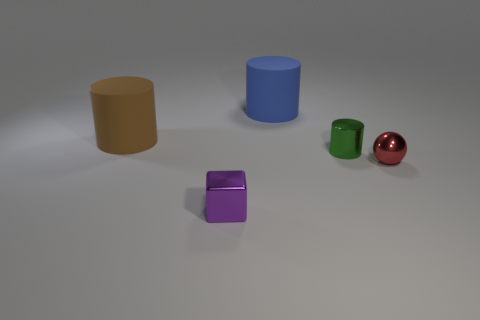There is a blue thing on the left side of the small metallic object that is behind the metal sphere; what number of large rubber cylinders are to the left of it?
Your answer should be very brief. 1. There is a matte cylinder that is on the right side of the brown matte cylinder; what number of metal things are on the left side of it?
Ensure brevity in your answer.  1. How many large brown things are behind the tiny green cylinder?
Your answer should be compact. 1. How many other things are the same size as the green shiny object?
Your answer should be compact. 2. What is the size of the other rubber object that is the same shape as the brown object?
Offer a very short reply. Large. What shape is the shiny thing that is in front of the small ball?
Keep it short and to the point. Cube. There is a small metallic object to the right of the shiny thing that is behind the red sphere; what color is it?
Your response must be concise. Red. What number of objects are big cylinders on the left side of the cube or shiny blocks?
Provide a succinct answer. 2. There is a blue object; does it have the same size as the shiny object behind the ball?
Make the answer very short. No. How many tiny objects are either brown cylinders or cylinders?
Make the answer very short. 1. 